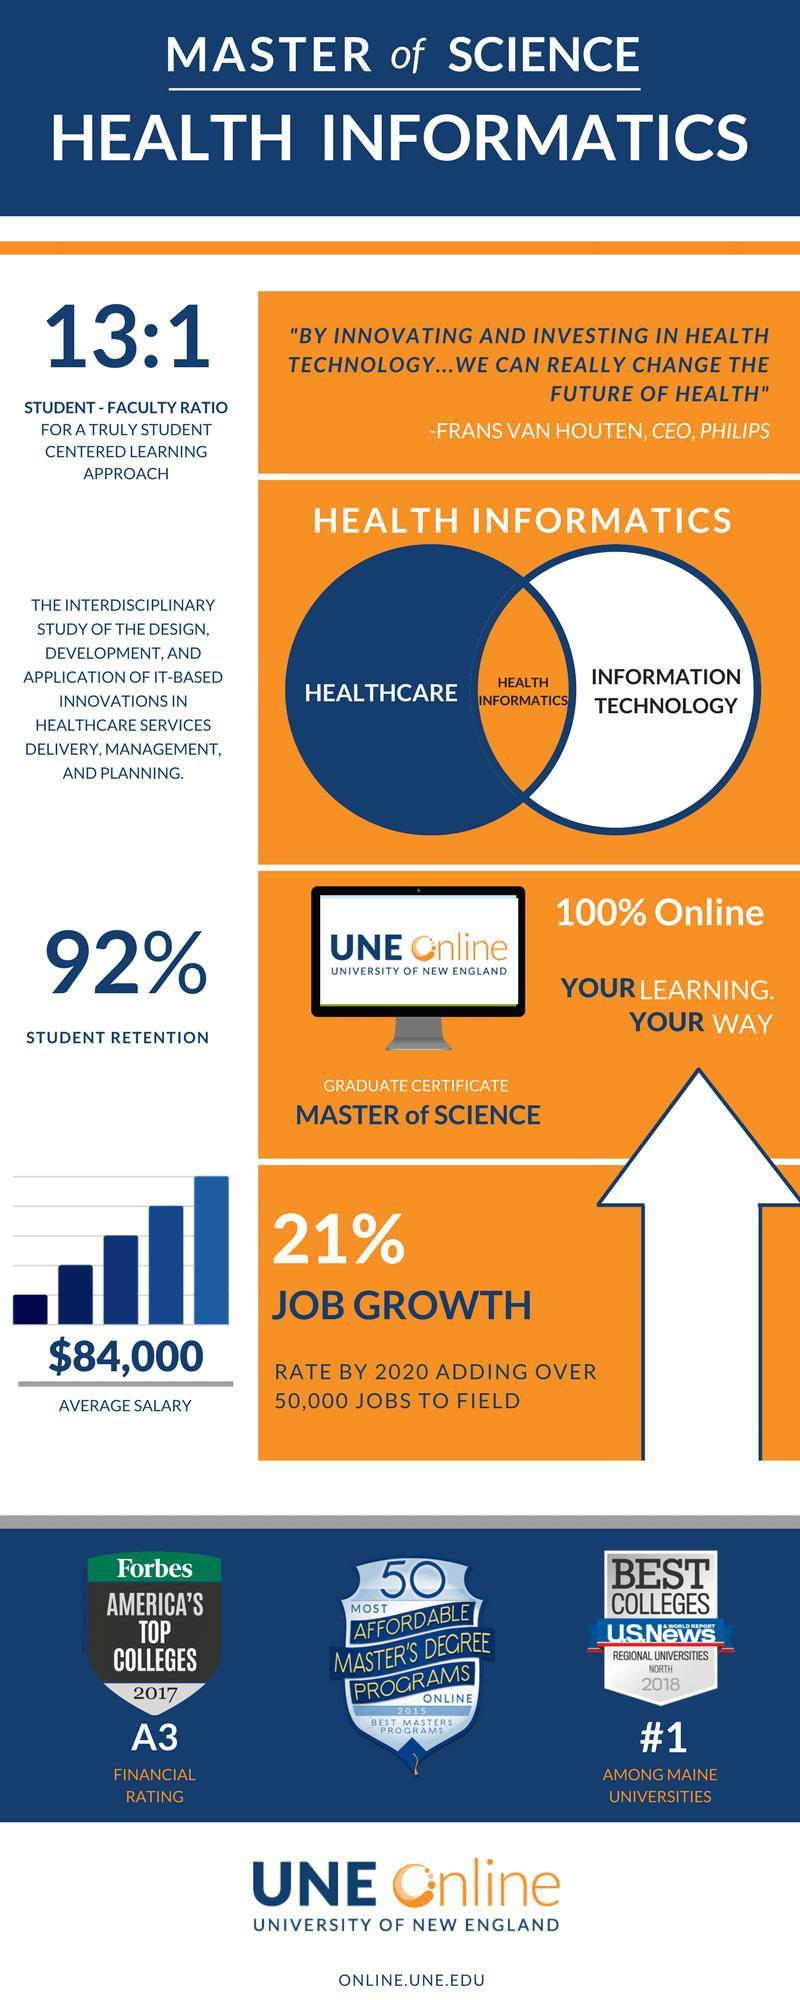Which all factors together constitute Health Informatics?
Answer the question with a short phrase. Healthcare, Information Technology 